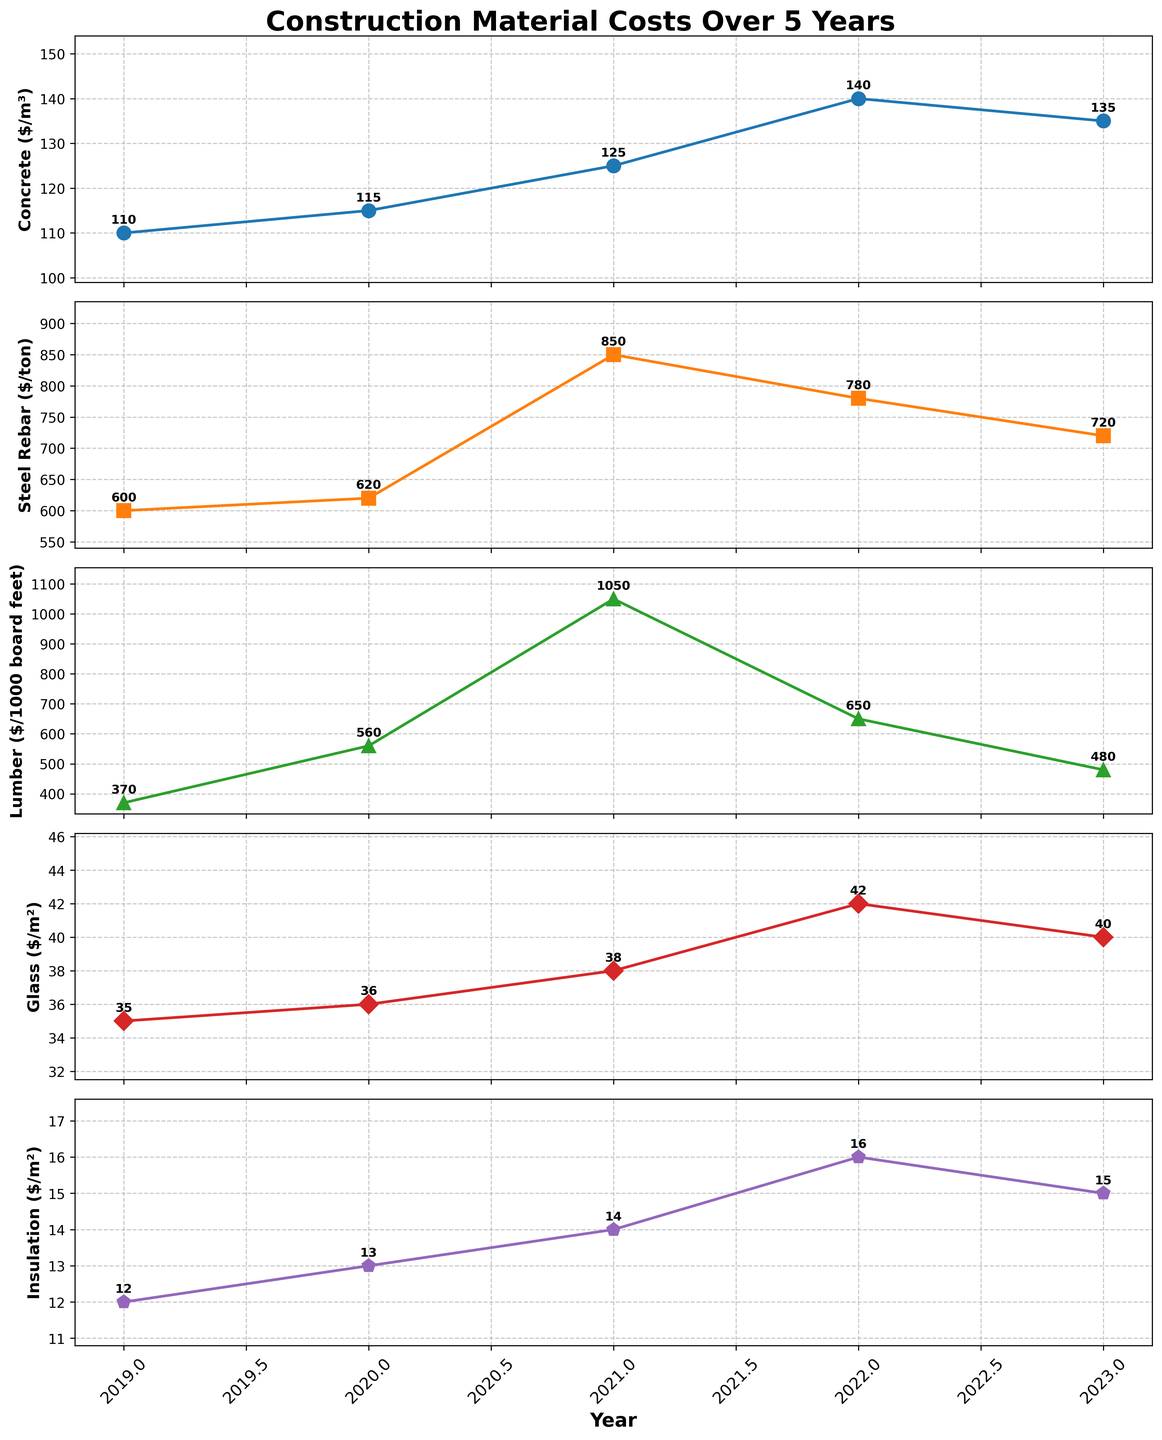What is the trend in the cost of concrete from 2019 to 2023? First, locate the 'Concrete' subplot. Observe the plotted points from 2019 to 2023. Note the increasing values from 110 in 2019 to a peak of 140 in 2022, then a drop to 135 in 2023.
Answer: The trend shows an increase until 2022 and then a slight decrease in 2023 Which year experienced the highest cost for steel rebar? Identify the highest point on the 'Steel Rebar' subplot. Notice the peak value of 850 in 2021. Verify by checking the plotted values for other years to ensure no higher values are shown.
Answer: 2021 How did the cost of lumber change between 2020 and 2021? Locate the 'Lumber' subplot, particularly the points for 2020 and 2021. The value jumps from 560 in 2020 to 1050 in 2021.
Answer: The cost almost doubled What was the average cost of insulation over the 5 years? Locate the 'Insulation' subplot and list all values from 2019 to 2023: 12, 13, 14, 16, 15. Add these values (12+13+14+16+15=70) and divide by the number of years (5).
Answer: 14 Which material experienced the smallest increase in cost from 2019 to 2023? Determine the increase for each material by subtracting the 2019 value from the 2023 value: Concrete (135-110=25), Steel Rebar (720-600=120), Lumber (480-370=110), Glass (40-35=5), Insulation (15-12=3). The smallest number is for Insulation.
Answer: Insulation How does the trend in insulation costs compare to that of glass from 2021 to 2023? Find both 'Insulation' and 'Glass' subplots. For 'Insulation', note an increase from 14 in 2021 to 16 in 2022, with a decrease to 15 in 2023. For 'Glass', values move from 38 in 2021 to 42 in 2022, and then drop to 40 in 2023. Both show a similar trend: increase from 2021 to 2022 and slight decrease from 2022 to 2023.
Answer: Both trends exhibit an increase followed by a slight decrease What is the difference in cost between the highest value of steel rebar and the lowest value of lumber over the years? Identify that the highest steel rebar value is 850 in 2021 and the lowest lumber is 370 in 2019. Subtract the latter from the former (850-370).
Answer: 480 How are the y-axis values distributed for the glass cost subplot? Examine the 'Glass' subplot. The values observed are: 35, 36, 38, 42, and 40. They cover a range between 35 and 42.
Answer: The values are spread between 35 and 42 Which material saw a peak cost followed by a consistent drop over the depicted years? Compare all subplots for a rise to a peak followed by a drop. Only 'Lumber' shows a peak at 1050 in 2021 followed by drops in subsequent years (650 and 480).
Answer: Lumber 